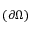<formula> <loc_0><loc_0><loc_500><loc_500>( \partial \Omega )</formula> 